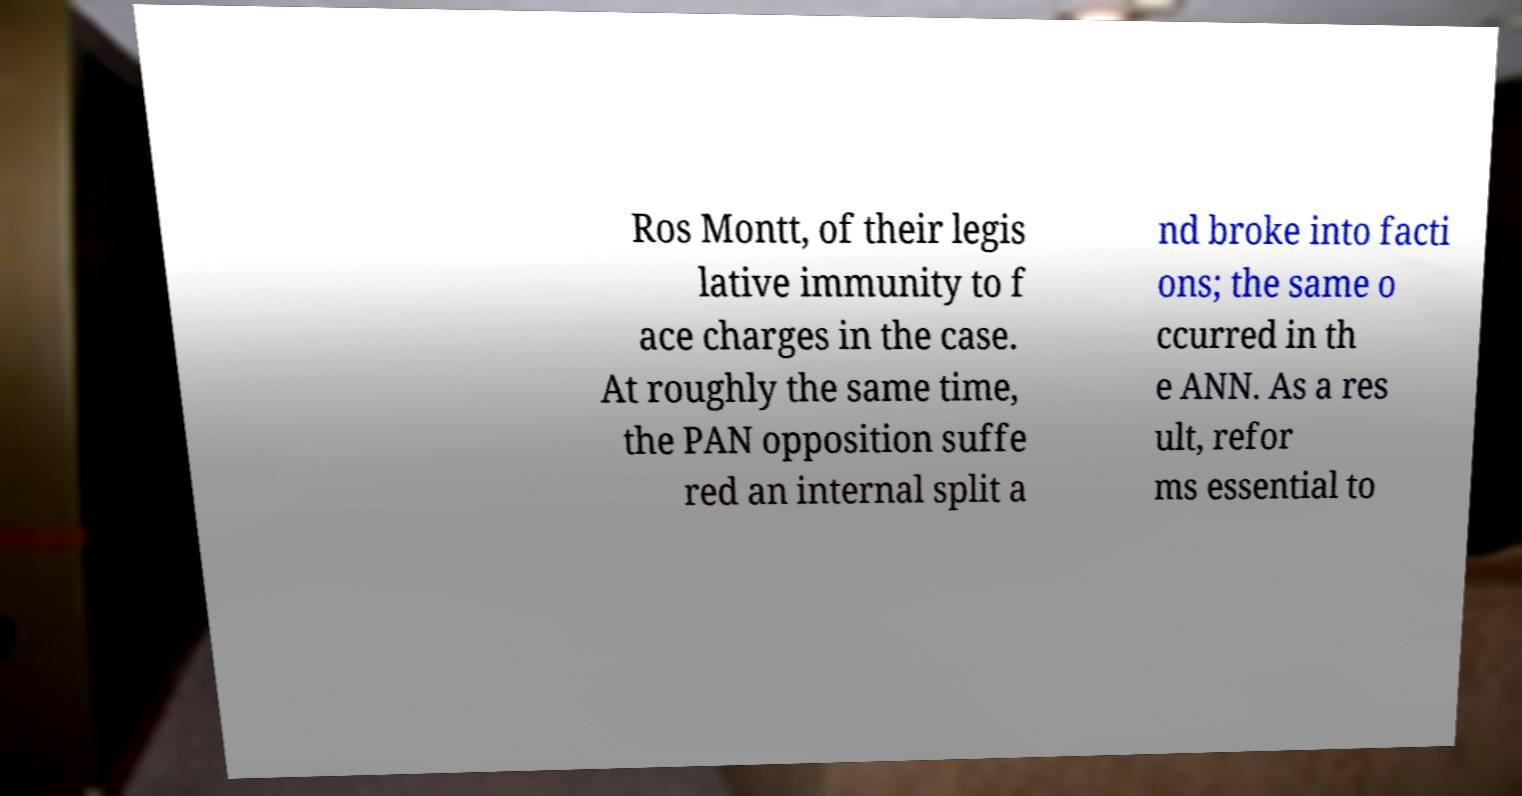Could you extract and type out the text from this image? Ros Montt, of their legis lative immunity to f ace charges in the case. At roughly the same time, the PAN opposition suffe red an internal split a nd broke into facti ons; the same o ccurred in th e ANN. As a res ult, refor ms essential to 